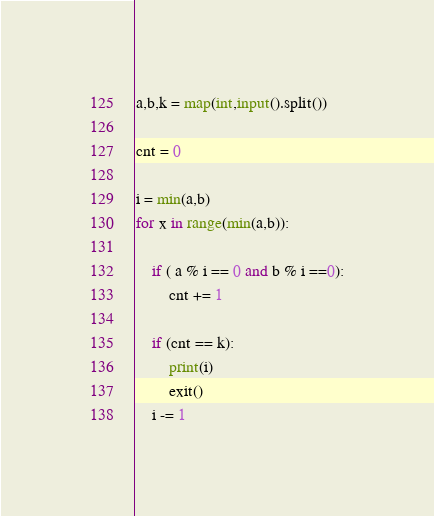Convert code to text. <code><loc_0><loc_0><loc_500><loc_500><_Python_>a,b,k = map(int,input().split())

cnt = 0

i = min(a,b)
for x in range(min(a,b)):
    
    if ( a % i == 0 and b % i ==0):
        cnt += 1       

    if (cnt == k):
        print(i)
        exit()
    i -= 1</code> 